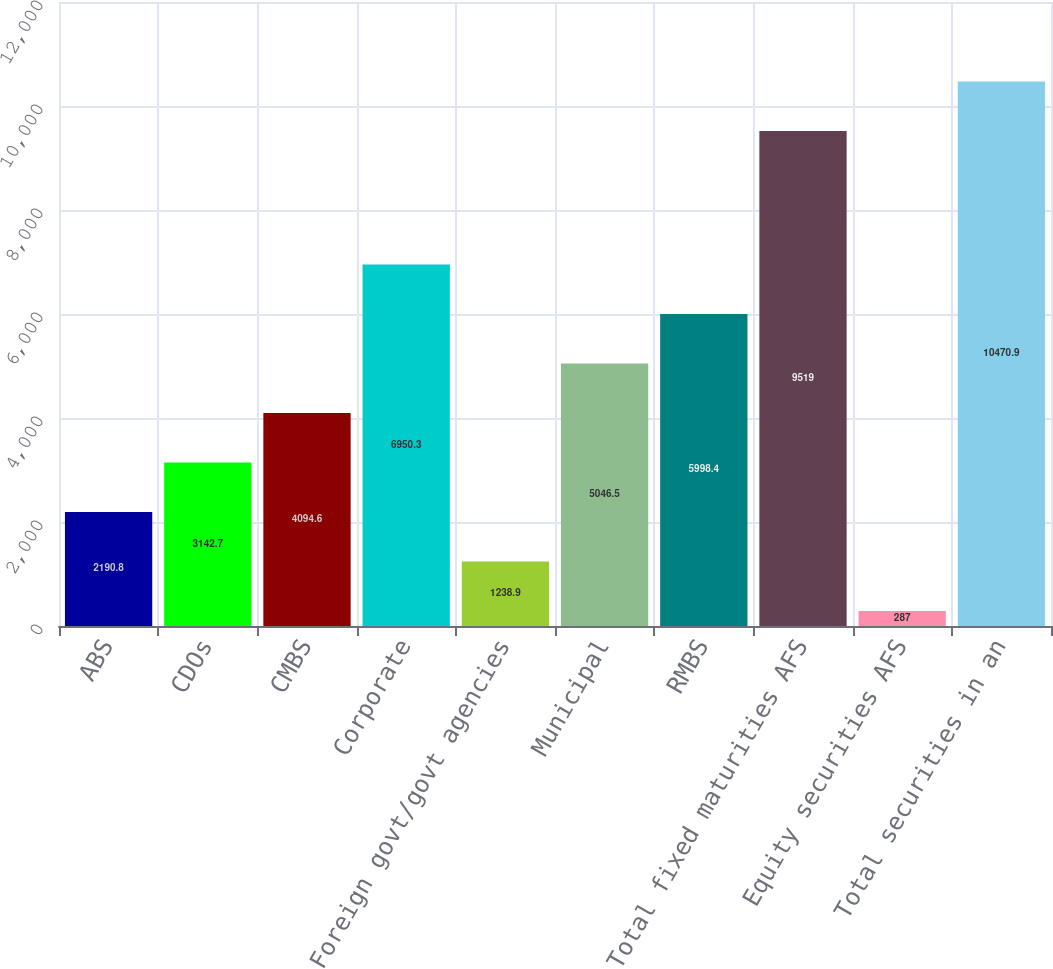<chart> <loc_0><loc_0><loc_500><loc_500><bar_chart><fcel>ABS<fcel>CDOs<fcel>CMBS<fcel>Corporate<fcel>Foreign govt/govt agencies<fcel>Municipal<fcel>RMBS<fcel>Total fixed maturities AFS<fcel>Equity securities AFS<fcel>Total securities in an<nl><fcel>2190.8<fcel>3142.7<fcel>4094.6<fcel>6950.3<fcel>1238.9<fcel>5046.5<fcel>5998.4<fcel>9519<fcel>287<fcel>10470.9<nl></chart> 